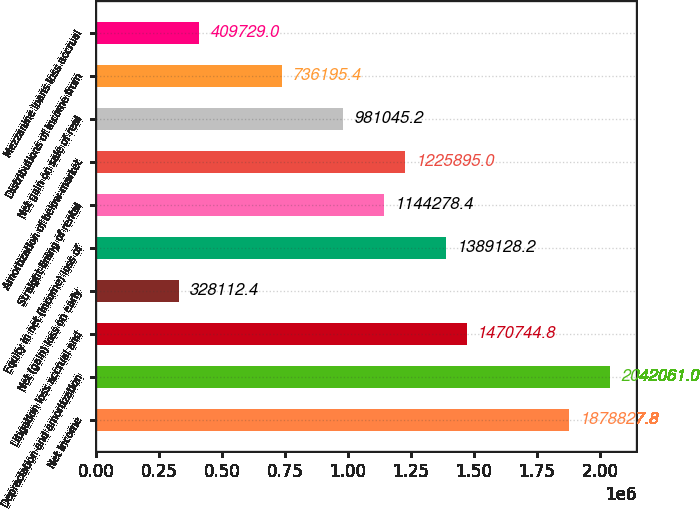<chart> <loc_0><loc_0><loc_500><loc_500><bar_chart><fcel>Net income<fcel>Depreciation and amortization<fcel>Litigation loss accrual and<fcel>Net (gain) loss on early<fcel>Equity in net (income) loss of<fcel>Straight-lining of rental<fcel>Amortization of below-market<fcel>Net gain on sale of real<fcel>Distributions of income from<fcel>Mezzanine loans loss accrual<nl><fcel>1.87883e+06<fcel>2.04206e+06<fcel>1.47074e+06<fcel>328112<fcel>1.38913e+06<fcel>1.14428e+06<fcel>1.2259e+06<fcel>981045<fcel>736195<fcel>409729<nl></chart> 